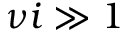<formula> <loc_0><loc_0><loc_500><loc_500>\nu i \gg 1</formula> 